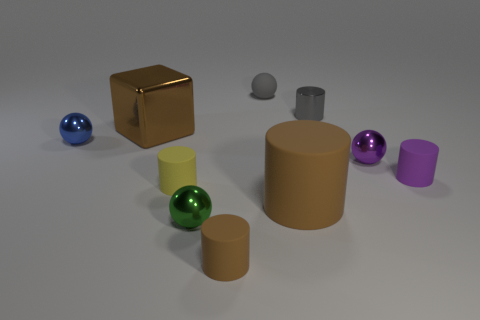How many spheres are there and what colors are they? There are four spheres in the image, each with a different color: blue, green, gray, and purple. 